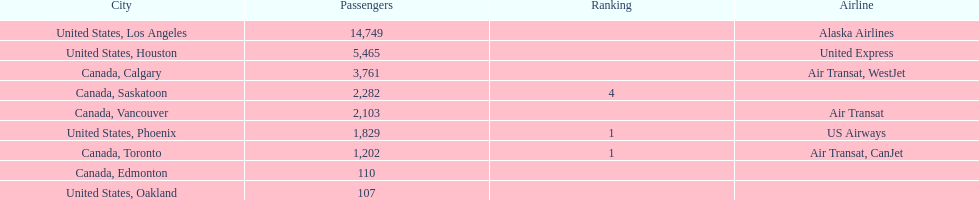The difference in passengers between los angeles and toronto 13,547. 